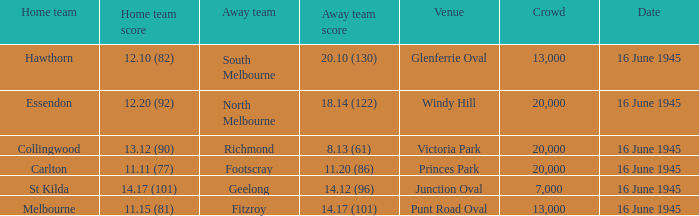What was the home team's score against south melbourne? 12.10 (82). Give me the full table as a dictionary. {'header': ['Home team', 'Home team score', 'Away team', 'Away team score', 'Venue', 'Crowd', 'Date'], 'rows': [['Hawthorn', '12.10 (82)', 'South Melbourne', '20.10 (130)', 'Glenferrie Oval', '13,000', '16 June 1945'], ['Essendon', '12.20 (92)', 'North Melbourne', '18.14 (122)', 'Windy Hill', '20,000', '16 June 1945'], ['Collingwood', '13.12 (90)', 'Richmond', '8.13 (61)', 'Victoria Park', '20,000', '16 June 1945'], ['Carlton', '11.11 (77)', 'Footscray', '11.20 (86)', 'Princes Park', '20,000', '16 June 1945'], ['St Kilda', '14.17 (101)', 'Geelong', '14.12 (96)', 'Junction Oval', '7,000', '16 June 1945'], ['Melbourne', '11.15 (81)', 'Fitzroy', '14.17 (101)', 'Punt Road Oval', '13,000', '16 June 1945']]} 